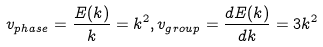<formula> <loc_0><loc_0><loc_500><loc_500>v _ { p h a s e } = \frac { E ( k ) } { k } = k ^ { 2 } , v _ { g r o u p } = \frac { d E ( k ) } { d k } = 3 k ^ { 2 }</formula> 